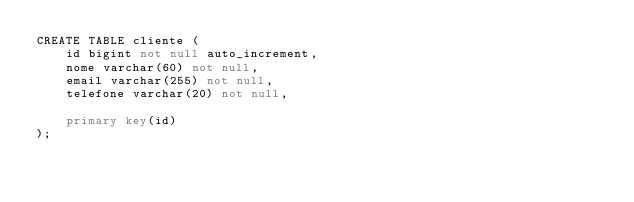<code> <loc_0><loc_0><loc_500><loc_500><_SQL_>CREATE TABLE cliente (
	id bigint not null auto_increment,
    nome varchar(60) not null,
    email varchar(255) not null,
    telefone varchar(20) not null,
    
    primary key(id)
);</code> 